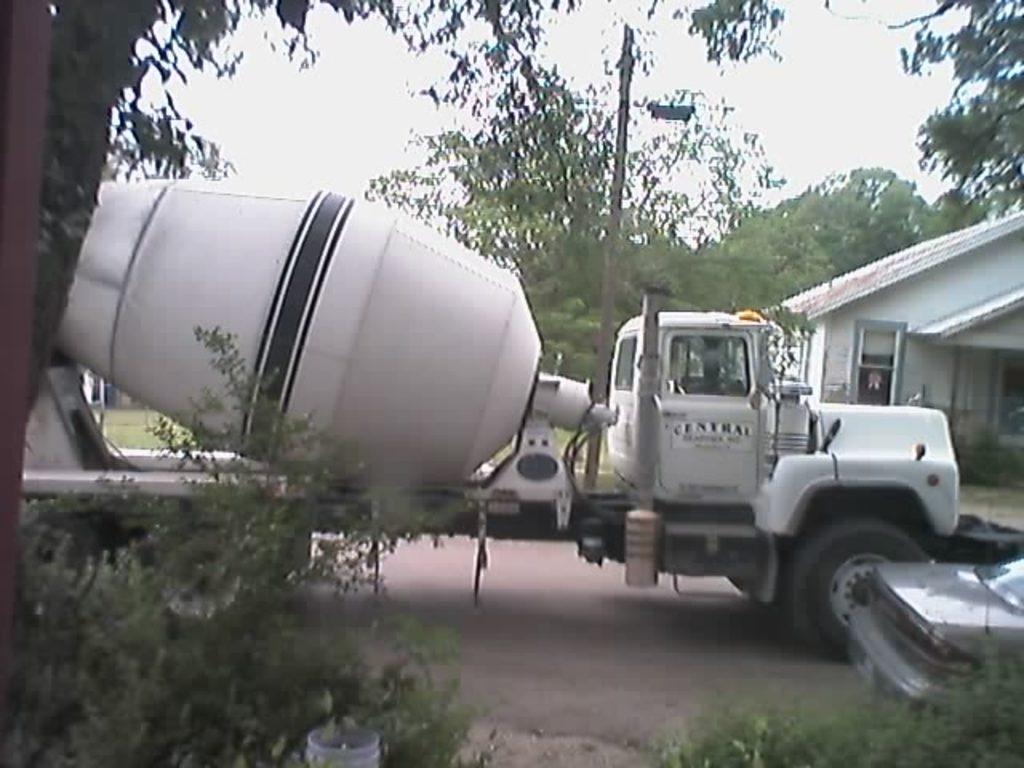How would you summarize this image in a sentence or two? In this image we can see a cement mixer machine and a car parked on the road. In the foreground of the image we can see a group of plants. In the background ,we can see a building ,pole and group of trees and sky. 